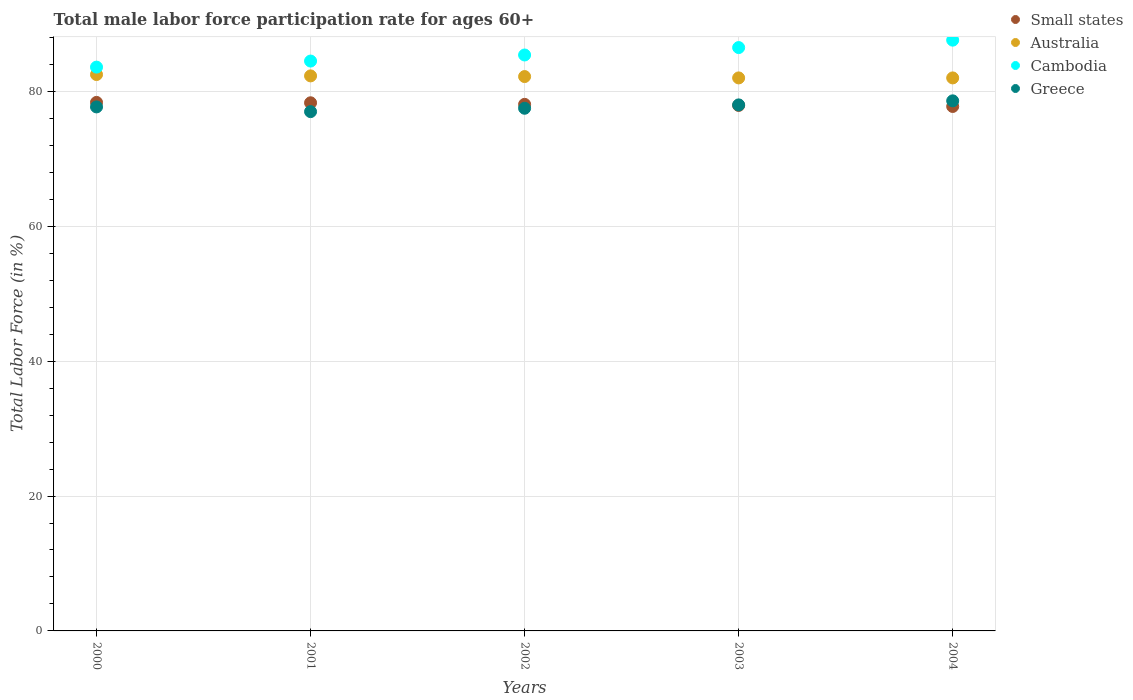Is the number of dotlines equal to the number of legend labels?
Your answer should be very brief. Yes. What is the male labor force participation rate in Cambodia in 2002?
Make the answer very short. 85.4. Across all years, what is the maximum male labor force participation rate in Greece?
Offer a terse response. 78.6. Across all years, what is the minimum male labor force participation rate in Cambodia?
Offer a terse response. 83.6. What is the total male labor force participation rate in Australia in the graph?
Provide a succinct answer. 411. What is the difference between the male labor force participation rate in Australia in 2000 and that in 2001?
Ensure brevity in your answer.  0.2. What is the difference between the male labor force participation rate in Small states in 2003 and the male labor force participation rate in Australia in 2000?
Make the answer very short. -4.58. What is the average male labor force participation rate in Cambodia per year?
Keep it short and to the point. 85.52. In the year 2001, what is the difference between the male labor force participation rate in Greece and male labor force participation rate in Small states?
Give a very brief answer. -1.31. What is the ratio of the male labor force participation rate in Cambodia in 2000 to that in 2003?
Provide a succinct answer. 0.97. What is the difference between the highest and the second highest male labor force participation rate in Cambodia?
Make the answer very short. 1.1. What is the difference between the highest and the lowest male labor force participation rate in Greece?
Provide a succinct answer. 1.6. Is it the case that in every year, the sum of the male labor force participation rate in Cambodia and male labor force participation rate in Australia  is greater than the sum of male labor force participation rate in Small states and male labor force participation rate in Greece?
Offer a terse response. Yes. How many dotlines are there?
Your answer should be compact. 4. What is the difference between two consecutive major ticks on the Y-axis?
Give a very brief answer. 20. Does the graph contain any zero values?
Provide a succinct answer. No. Does the graph contain grids?
Provide a short and direct response. Yes. How many legend labels are there?
Your answer should be very brief. 4. How are the legend labels stacked?
Give a very brief answer. Vertical. What is the title of the graph?
Provide a short and direct response. Total male labor force participation rate for ages 60+. What is the Total Labor Force (in %) of Small states in 2000?
Provide a short and direct response. 78.37. What is the Total Labor Force (in %) in Australia in 2000?
Ensure brevity in your answer.  82.5. What is the Total Labor Force (in %) in Cambodia in 2000?
Offer a very short reply. 83.6. What is the Total Labor Force (in %) of Greece in 2000?
Give a very brief answer. 77.7. What is the Total Labor Force (in %) in Small states in 2001?
Give a very brief answer. 78.31. What is the Total Labor Force (in %) in Australia in 2001?
Offer a very short reply. 82.3. What is the Total Labor Force (in %) in Cambodia in 2001?
Give a very brief answer. 84.5. What is the Total Labor Force (in %) of Greece in 2001?
Offer a very short reply. 77. What is the Total Labor Force (in %) of Small states in 2002?
Keep it short and to the point. 78.08. What is the Total Labor Force (in %) in Australia in 2002?
Provide a short and direct response. 82.2. What is the Total Labor Force (in %) in Cambodia in 2002?
Make the answer very short. 85.4. What is the Total Labor Force (in %) in Greece in 2002?
Provide a short and direct response. 77.5. What is the Total Labor Force (in %) of Small states in 2003?
Your answer should be compact. 77.92. What is the Total Labor Force (in %) in Cambodia in 2003?
Your answer should be very brief. 86.5. What is the Total Labor Force (in %) in Small states in 2004?
Your answer should be compact. 77.77. What is the Total Labor Force (in %) in Cambodia in 2004?
Your answer should be compact. 87.6. What is the Total Labor Force (in %) of Greece in 2004?
Ensure brevity in your answer.  78.6. Across all years, what is the maximum Total Labor Force (in %) of Small states?
Your answer should be compact. 78.37. Across all years, what is the maximum Total Labor Force (in %) in Australia?
Your answer should be compact. 82.5. Across all years, what is the maximum Total Labor Force (in %) in Cambodia?
Offer a terse response. 87.6. Across all years, what is the maximum Total Labor Force (in %) in Greece?
Your answer should be compact. 78.6. Across all years, what is the minimum Total Labor Force (in %) in Small states?
Provide a succinct answer. 77.77. Across all years, what is the minimum Total Labor Force (in %) in Australia?
Give a very brief answer. 82. Across all years, what is the minimum Total Labor Force (in %) in Cambodia?
Provide a short and direct response. 83.6. What is the total Total Labor Force (in %) in Small states in the graph?
Your answer should be compact. 390.45. What is the total Total Labor Force (in %) of Australia in the graph?
Make the answer very short. 411. What is the total Total Labor Force (in %) in Cambodia in the graph?
Keep it short and to the point. 427.6. What is the total Total Labor Force (in %) in Greece in the graph?
Offer a very short reply. 388.8. What is the difference between the Total Labor Force (in %) in Small states in 2000 and that in 2001?
Ensure brevity in your answer.  0.06. What is the difference between the Total Labor Force (in %) of Greece in 2000 and that in 2001?
Your answer should be very brief. 0.7. What is the difference between the Total Labor Force (in %) in Small states in 2000 and that in 2002?
Provide a short and direct response. 0.29. What is the difference between the Total Labor Force (in %) of Cambodia in 2000 and that in 2002?
Offer a terse response. -1.8. What is the difference between the Total Labor Force (in %) of Greece in 2000 and that in 2002?
Provide a succinct answer. 0.2. What is the difference between the Total Labor Force (in %) in Small states in 2000 and that in 2003?
Offer a very short reply. 0.45. What is the difference between the Total Labor Force (in %) in Cambodia in 2000 and that in 2003?
Your answer should be compact. -2.9. What is the difference between the Total Labor Force (in %) in Greece in 2000 and that in 2003?
Make the answer very short. -0.3. What is the difference between the Total Labor Force (in %) in Small states in 2000 and that in 2004?
Your response must be concise. 0.6. What is the difference between the Total Labor Force (in %) of Greece in 2000 and that in 2004?
Give a very brief answer. -0.9. What is the difference between the Total Labor Force (in %) of Small states in 2001 and that in 2002?
Make the answer very short. 0.23. What is the difference between the Total Labor Force (in %) of Australia in 2001 and that in 2002?
Give a very brief answer. 0.1. What is the difference between the Total Labor Force (in %) in Cambodia in 2001 and that in 2002?
Offer a terse response. -0.9. What is the difference between the Total Labor Force (in %) in Greece in 2001 and that in 2002?
Your answer should be compact. -0.5. What is the difference between the Total Labor Force (in %) in Small states in 2001 and that in 2003?
Offer a terse response. 0.39. What is the difference between the Total Labor Force (in %) of Cambodia in 2001 and that in 2003?
Keep it short and to the point. -2. What is the difference between the Total Labor Force (in %) in Greece in 2001 and that in 2003?
Your answer should be very brief. -1. What is the difference between the Total Labor Force (in %) of Small states in 2001 and that in 2004?
Make the answer very short. 0.55. What is the difference between the Total Labor Force (in %) of Australia in 2001 and that in 2004?
Your response must be concise. 0.3. What is the difference between the Total Labor Force (in %) of Small states in 2002 and that in 2003?
Your answer should be compact. 0.16. What is the difference between the Total Labor Force (in %) of Australia in 2002 and that in 2003?
Offer a very short reply. 0.2. What is the difference between the Total Labor Force (in %) of Small states in 2002 and that in 2004?
Your response must be concise. 0.31. What is the difference between the Total Labor Force (in %) of Cambodia in 2002 and that in 2004?
Keep it short and to the point. -2.2. What is the difference between the Total Labor Force (in %) in Small states in 2003 and that in 2004?
Make the answer very short. 0.15. What is the difference between the Total Labor Force (in %) in Australia in 2003 and that in 2004?
Make the answer very short. 0. What is the difference between the Total Labor Force (in %) of Cambodia in 2003 and that in 2004?
Offer a very short reply. -1.1. What is the difference between the Total Labor Force (in %) of Greece in 2003 and that in 2004?
Give a very brief answer. -0.6. What is the difference between the Total Labor Force (in %) in Small states in 2000 and the Total Labor Force (in %) in Australia in 2001?
Provide a short and direct response. -3.93. What is the difference between the Total Labor Force (in %) of Small states in 2000 and the Total Labor Force (in %) of Cambodia in 2001?
Keep it short and to the point. -6.13. What is the difference between the Total Labor Force (in %) of Small states in 2000 and the Total Labor Force (in %) of Greece in 2001?
Offer a very short reply. 1.37. What is the difference between the Total Labor Force (in %) in Small states in 2000 and the Total Labor Force (in %) in Australia in 2002?
Your answer should be very brief. -3.83. What is the difference between the Total Labor Force (in %) in Small states in 2000 and the Total Labor Force (in %) in Cambodia in 2002?
Offer a terse response. -7.03. What is the difference between the Total Labor Force (in %) in Small states in 2000 and the Total Labor Force (in %) in Greece in 2002?
Give a very brief answer. 0.87. What is the difference between the Total Labor Force (in %) of Australia in 2000 and the Total Labor Force (in %) of Cambodia in 2002?
Your answer should be very brief. -2.9. What is the difference between the Total Labor Force (in %) in Small states in 2000 and the Total Labor Force (in %) in Australia in 2003?
Provide a succinct answer. -3.63. What is the difference between the Total Labor Force (in %) in Small states in 2000 and the Total Labor Force (in %) in Cambodia in 2003?
Offer a very short reply. -8.13. What is the difference between the Total Labor Force (in %) of Small states in 2000 and the Total Labor Force (in %) of Greece in 2003?
Ensure brevity in your answer.  0.37. What is the difference between the Total Labor Force (in %) in Australia in 2000 and the Total Labor Force (in %) in Cambodia in 2003?
Offer a terse response. -4. What is the difference between the Total Labor Force (in %) in Small states in 2000 and the Total Labor Force (in %) in Australia in 2004?
Give a very brief answer. -3.63. What is the difference between the Total Labor Force (in %) in Small states in 2000 and the Total Labor Force (in %) in Cambodia in 2004?
Offer a very short reply. -9.23. What is the difference between the Total Labor Force (in %) in Small states in 2000 and the Total Labor Force (in %) in Greece in 2004?
Make the answer very short. -0.23. What is the difference between the Total Labor Force (in %) in Australia in 2000 and the Total Labor Force (in %) in Cambodia in 2004?
Provide a succinct answer. -5.1. What is the difference between the Total Labor Force (in %) in Australia in 2000 and the Total Labor Force (in %) in Greece in 2004?
Your answer should be very brief. 3.9. What is the difference between the Total Labor Force (in %) of Cambodia in 2000 and the Total Labor Force (in %) of Greece in 2004?
Provide a succinct answer. 5. What is the difference between the Total Labor Force (in %) in Small states in 2001 and the Total Labor Force (in %) in Australia in 2002?
Your response must be concise. -3.89. What is the difference between the Total Labor Force (in %) in Small states in 2001 and the Total Labor Force (in %) in Cambodia in 2002?
Provide a short and direct response. -7.09. What is the difference between the Total Labor Force (in %) in Small states in 2001 and the Total Labor Force (in %) in Greece in 2002?
Your response must be concise. 0.81. What is the difference between the Total Labor Force (in %) in Australia in 2001 and the Total Labor Force (in %) in Cambodia in 2002?
Provide a short and direct response. -3.1. What is the difference between the Total Labor Force (in %) in Cambodia in 2001 and the Total Labor Force (in %) in Greece in 2002?
Give a very brief answer. 7. What is the difference between the Total Labor Force (in %) in Small states in 2001 and the Total Labor Force (in %) in Australia in 2003?
Your answer should be very brief. -3.69. What is the difference between the Total Labor Force (in %) of Small states in 2001 and the Total Labor Force (in %) of Cambodia in 2003?
Your answer should be compact. -8.19. What is the difference between the Total Labor Force (in %) of Small states in 2001 and the Total Labor Force (in %) of Greece in 2003?
Offer a terse response. 0.31. What is the difference between the Total Labor Force (in %) of Australia in 2001 and the Total Labor Force (in %) of Cambodia in 2003?
Keep it short and to the point. -4.2. What is the difference between the Total Labor Force (in %) of Australia in 2001 and the Total Labor Force (in %) of Greece in 2003?
Keep it short and to the point. 4.3. What is the difference between the Total Labor Force (in %) in Cambodia in 2001 and the Total Labor Force (in %) in Greece in 2003?
Make the answer very short. 6.5. What is the difference between the Total Labor Force (in %) in Small states in 2001 and the Total Labor Force (in %) in Australia in 2004?
Ensure brevity in your answer.  -3.69. What is the difference between the Total Labor Force (in %) in Small states in 2001 and the Total Labor Force (in %) in Cambodia in 2004?
Offer a very short reply. -9.29. What is the difference between the Total Labor Force (in %) in Small states in 2001 and the Total Labor Force (in %) in Greece in 2004?
Make the answer very short. -0.29. What is the difference between the Total Labor Force (in %) of Cambodia in 2001 and the Total Labor Force (in %) of Greece in 2004?
Provide a succinct answer. 5.9. What is the difference between the Total Labor Force (in %) in Small states in 2002 and the Total Labor Force (in %) in Australia in 2003?
Ensure brevity in your answer.  -3.92. What is the difference between the Total Labor Force (in %) of Small states in 2002 and the Total Labor Force (in %) of Cambodia in 2003?
Your response must be concise. -8.42. What is the difference between the Total Labor Force (in %) in Small states in 2002 and the Total Labor Force (in %) in Greece in 2003?
Give a very brief answer. 0.08. What is the difference between the Total Labor Force (in %) of Cambodia in 2002 and the Total Labor Force (in %) of Greece in 2003?
Offer a terse response. 7.4. What is the difference between the Total Labor Force (in %) of Small states in 2002 and the Total Labor Force (in %) of Australia in 2004?
Provide a short and direct response. -3.92. What is the difference between the Total Labor Force (in %) of Small states in 2002 and the Total Labor Force (in %) of Cambodia in 2004?
Keep it short and to the point. -9.52. What is the difference between the Total Labor Force (in %) in Small states in 2002 and the Total Labor Force (in %) in Greece in 2004?
Give a very brief answer. -0.52. What is the difference between the Total Labor Force (in %) of Australia in 2002 and the Total Labor Force (in %) of Cambodia in 2004?
Offer a terse response. -5.4. What is the difference between the Total Labor Force (in %) in Australia in 2002 and the Total Labor Force (in %) in Greece in 2004?
Provide a short and direct response. 3.6. What is the difference between the Total Labor Force (in %) of Cambodia in 2002 and the Total Labor Force (in %) of Greece in 2004?
Ensure brevity in your answer.  6.8. What is the difference between the Total Labor Force (in %) of Small states in 2003 and the Total Labor Force (in %) of Australia in 2004?
Ensure brevity in your answer.  -4.08. What is the difference between the Total Labor Force (in %) in Small states in 2003 and the Total Labor Force (in %) in Cambodia in 2004?
Offer a terse response. -9.68. What is the difference between the Total Labor Force (in %) of Small states in 2003 and the Total Labor Force (in %) of Greece in 2004?
Offer a very short reply. -0.68. What is the difference between the Total Labor Force (in %) in Cambodia in 2003 and the Total Labor Force (in %) in Greece in 2004?
Your response must be concise. 7.9. What is the average Total Labor Force (in %) in Small states per year?
Give a very brief answer. 78.09. What is the average Total Labor Force (in %) of Australia per year?
Offer a very short reply. 82.2. What is the average Total Labor Force (in %) in Cambodia per year?
Your answer should be compact. 85.52. What is the average Total Labor Force (in %) in Greece per year?
Keep it short and to the point. 77.76. In the year 2000, what is the difference between the Total Labor Force (in %) in Small states and Total Labor Force (in %) in Australia?
Provide a succinct answer. -4.13. In the year 2000, what is the difference between the Total Labor Force (in %) of Small states and Total Labor Force (in %) of Cambodia?
Make the answer very short. -5.23. In the year 2000, what is the difference between the Total Labor Force (in %) of Small states and Total Labor Force (in %) of Greece?
Provide a succinct answer. 0.67. In the year 2000, what is the difference between the Total Labor Force (in %) in Australia and Total Labor Force (in %) in Cambodia?
Provide a short and direct response. -1.1. In the year 2000, what is the difference between the Total Labor Force (in %) in Australia and Total Labor Force (in %) in Greece?
Offer a very short reply. 4.8. In the year 2001, what is the difference between the Total Labor Force (in %) of Small states and Total Labor Force (in %) of Australia?
Keep it short and to the point. -3.99. In the year 2001, what is the difference between the Total Labor Force (in %) of Small states and Total Labor Force (in %) of Cambodia?
Your response must be concise. -6.19. In the year 2001, what is the difference between the Total Labor Force (in %) in Small states and Total Labor Force (in %) in Greece?
Give a very brief answer. 1.31. In the year 2002, what is the difference between the Total Labor Force (in %) of Small states and Total Labor Force (in %) of Australia?
Ensure brevity in your answer.  -4.12. In the year 2002, what is the difference between the Total Labor Force (in %) in Small states and Total Labor Force (in %) in Cambodia?
Your answer should be compact. -7.32. In the year 2002, what is the difference between the Total Labor Force (in %) of Small states and Total Labor Force (in %) of Greece?
Your answer should be very brief. 0.58. In the year 2002, what is the difference between the Total Labor Force (in %) of Australia and Total Labor Force (in %) of Cambodia?
Provide a succinct answer. -3.2. In the year 2003, what is the difference between the Total Labor Force (in %) in Small states and Total Labor Force (in %) in Australia?
Keep it short and to the point. -4.08. In the year 2003, what is the difference between the Total Labor Force (in %) of Small states and Total Labor Force (in %) of Cambodia?
Your response must be concise. -8.58. In the year 2003, what is the difference between the Total Labor Force (in %) of Small states and Total Labor Force (in %) of Greece?
Your answer should be very brief. -0.08. In the year 2003, what is the difference between the Total Labor Force (in %) in Australia and Total Labor Force (in %) in Cambodia?
Your response must be concise. -4.5. In the year 2003, what is the difference between the Total Labor Force (in %) of Australia and Total Labor Force (in %) of Greece?
Give a very brief answer. 4. In the year 2003, what is the difference between the Total Labor Force (in %) in Cambodia and Total Labor Force (in %) in Greece?
Provide a short and direct response. 8.5. In the year 2004, what is the difference between the Total Labor Force (in %) of Small states and Total Labor Force (in %) of Australia?
Offer a terse response. -4.23. In the year 2004, what is the difference between the Total Labor Force (in %) of Small states and Total Labor Force (in %) of Cambodia?
Your answer should be very brief. -9.83. In the year 2004, what is the difference between the Total Labor Force (in %) in Small states and Total Labor Force (in %) in Greece?
Provide a succinct answer. -0.83. In the year 2004, what is the difference between the Total Labor Force (in %) of Cambodia and Total Labor Force (in %) of Greece?
Ensure brevity in your answer.  9. What is the ratio of the Total Labor Force (in %) of Small states in 2000 to that in 2001?
Your response must be concise. 1. What is the ratio of the Total Labor Force (in %) in Australia in 2000 to that in 2001?
Offer a very short reply. 1. What is the ratio of the Total Labor Force (in %) in Cambodia in 2000 to that in 2001?
Your answer should be compact. 0.99. What is the ratio of the Total Labor Force (in %) in Greece in 2000 to that in 2001?
Your answer should be compact. 1.01. What is the ratio of the Total Labor Force (in %) in Small states in 2000 to that in 2002?
Provide a short and direct response. 1. What is the ratio of the Total Labor Force (in %) in Australia in 2000 to that in 2002?
Your answer should be very brief. 1. What is the ratio of the Total Labor Force (in %) of Cambodia in 2000 to that in 2002?
Make the answer very short. 0.98. What is the ratio of the Total Labor Force (in %) of Greece in 2000 to that in 2002?
Your answer should be very brief. 1. What is the ratio of the Total Labor Force (in %) of Small states in 2000 to that in 2003?
Your response must be concise. 1.01. What is the ratio of the Total Labor Force (in %) of Australia in 2000 to that in 2003?
Your response must be concise. 1.01. What is the ratio of the Total Labor Force (in %) in Cambodia in 2000 to that in 2003?
Keep it short and to the point. 0.97. What is the ratio of the Total Labor Force (in %) of Small states in 2000 to that in 2004?
Keep it short and to the point. 1.01. What is the ratio of the Total Labor Force (in %) of Australia in 2000 to that in 2004?
Your response must be concise. 1.01. What is the ratio of the Total Labor Force (in %) in Cambodia in 2000 to that in 2004?
Give a very brief answer. 0.95. What is the ratio of the Total Labor Force (in %) of Small states in 2001 to that in 2002?
Provide a succinct answer. 1. What is the ratio of the Total Labor Force (in %) in Australia in 2001 to that in 2002?
Provide a succinct answer. 1. What is the ratio of the Total Labor Force (in %) in Cambodia in 2001 to that in 2002?
Your answer should be very brief. 0.99. What is the ratio of the Total Labor Force (in %) of Greece in 2001 to that in 2002?
Give a very brief answer. 0.99. What is the ratio of the Total Labor Force (in %) of Cambodia in 2001 to that in 2003?
Keep it short and to the point. 0.98. What is the ratio of the Total Labor Force (in %) of Greece in 2001 to that in 2003?
Make the answer very short. 0.99. What is the ratio of the Total Labor Force (in %) of Small states in 2001 to that in 2004?
Make the answer very short. 1.01. What is the ratio of the Total Labor Force (in %) in Australia in 2001 to that in 2004?
Your response must be concise. 1. What is the ratio of the Total Labor Force (in %) in Cambodia in 2001 to that in 2004?
Your answer should be compact. 0.96. What is the ratio of the Total Labor Force (in %) in Greece in 2001 to that in 2004?
Ensure brevity in your answer.  0.98. What is the ratio of the Total Labor Force (in %) in Small states in 2002 to that in 2003?
Provide a succinct answer. 1. What is the ratio of the Total Labor Force (in %) of Cambodia in 2002 to that in 2003?
Ensure brevity in your answer.  0.99. What is the ratio of the Total Labor Force (in %) in Small states in 2002 to that in 2004?
Offer a terse response. 1. What is the ratio of the Total Labor Force (in %) in Australia in 2002 to that in 2004?
Give a very brief answer. 1. What is the ratio of the Total Labor Force (in %) of Cambodia in 2002 to that in 2004?
Your response must be concise. 0.97. What is the ratio of the Total Labor Force (in %) in Australia in 2003 to that in 2004?
Provide a succinct answer. 1. What is the ratio of the Total Labor Force (in %) in Cambodia in 2003 to that in 2004?
Provide a succinct answer. 0.99. What is the ratio of the Total Labor Force (in %) of Greece in 2003 to that in 2004?
Make the answer very short. 0.99. What is the difference between the highest and the second highest Total Labor Force (in %) of Small states?
Offer a terse response. 0.06. What is the difference between the highest and the lowest Total Labor Force (in %) of Small states?
Ensure brevity in your answer.  0.6. 